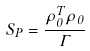<formula> <loc_0><loc_0><loc_500><loc_500>S _ { P } = \frac { \rho ^ { T } _ { 0 } \rho _ { 0 } } { \Gamma }</formula> 